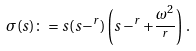Convert formula to latex. <formula><loc_0><loc_0><loc_500><loc_500>\sigma ( s ) \colon = s ( s - ^ { r } ) \left ( s - ^ { r } + \frac { \omega ^ { 2 } } { ^ { r } } \right ) \, .</formula> 